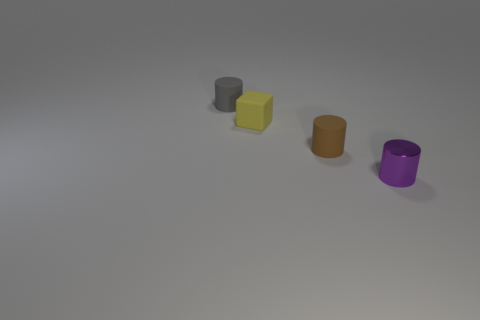What number of objects are tiny brown objects to the left of the purple metallic thing or small objects that are on the right side of the small gray rubber thing?
Give a very brief answer. 3. There is a rubber cylinder on the right side of the gray cylinder; what number of gray objects are behind it?
Offer a terse response. 1. Does the thing on the left side of the small yellow matte object have the same shape as the rubber thing in front of the tiny rubber block?
Your answer should be very brief. Yes. Is there a cube made of the same material as the small brown thing?
Ensure brevity in your answer.  Yes. How many metal objects are yellow things or tiny purple cubes?
Provide a succinct answer. 0. What shape is the object in front of the small rubber cylinder that is in front of the yellow rubber block?
Offer a very short reply. Cylinder. Is the number of tiny cylinders that are left of the small gray thing less than the number of big red metal balls?
Provide a short and direct response. No. What shape is the gray rubber thing?
Make the answer very short. Cylinder. What size is the rubber cylinder that is right of the gray cylinder?
Give a very brief answer. Small. There is a metal thing that is the same size as the gray cylinder; what color is it?
Keep it short and to the point. Purple. 